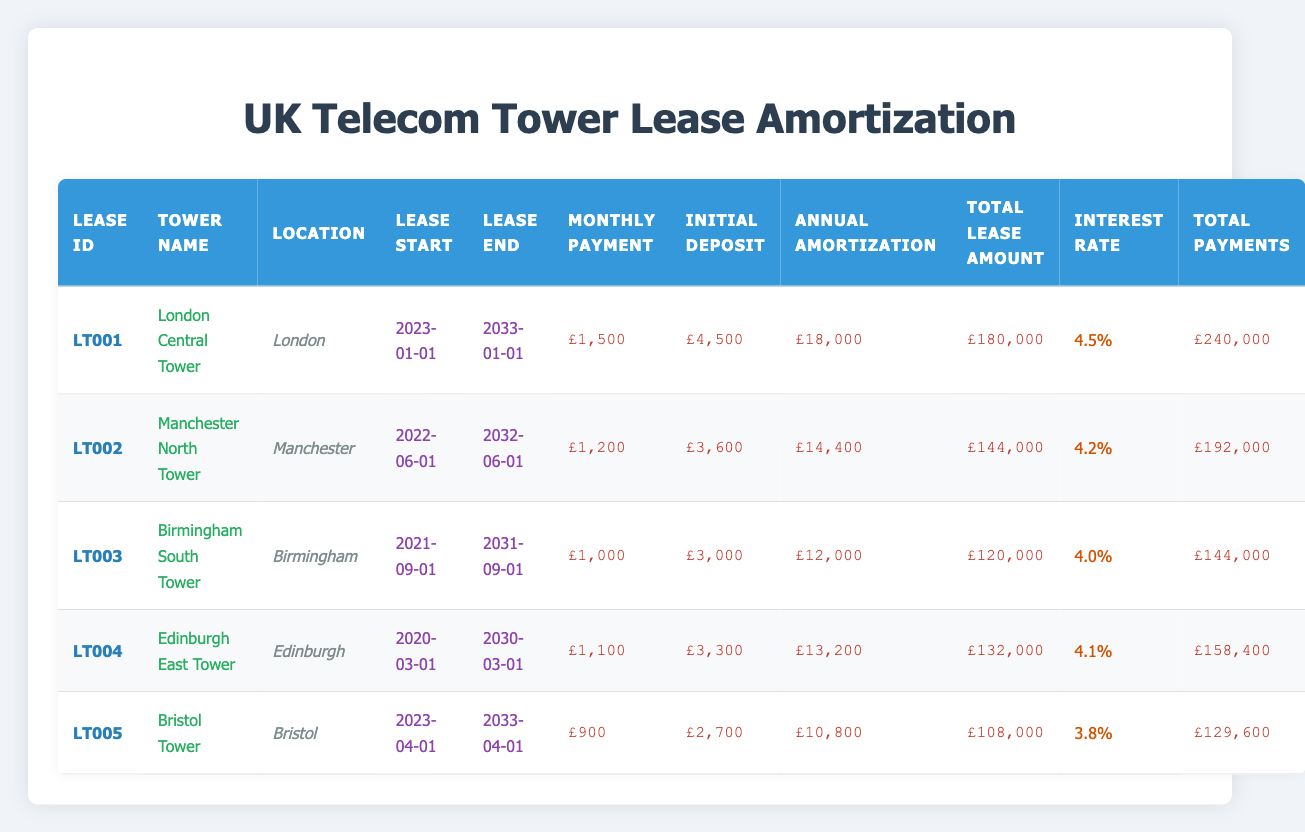What is the monthly lease payment for the "Bristol Tower"? By looking at the table, the entry for "Bristol Tower" indicates that the monthly lease payment is £900.
Answer: £900 Which tower has the highest total payments? Reviewing the "Total Payments" column, "London Central Tower" has the highest total payments of £240,000 compared to other towers.
Answer: £240,000 What is the average annual amortization amount across all telecom tower leases? The annual amortization amounts are £18,000, £14,400, £12,000, £13,200, and £10,800. Adding these together (18,000 + 14,400 + 12,000 + 13,200 + 10,800 = 68,400) and dividing by the number of leases (5) gives an average of £13,680.
Answer: £13,680 Is the lease for "Edinburgh East Tower" longer than 10 years? The lease starts on 2020-03-01 and ends on 2030-03-01, which is exactly 10 years, so it is not longer than 10 years.
Answer: No What is the difference between the total lease amounts of the "London Central Tower" and "Bristol Tower"? The total lease amounts are £180,000 for "London Central Tower" and £108,000 for "Bristol Tower". The difference is £180,000 - £108,000 = £72,000.
Answer: £72,000 Which tower has a lower interest rate: "Bristol Tower" or "Manchester North Tower"? "Bristol Tower" has an interest rate of 3.8%, while "Manchester North Tower" has an interest rate of 4.2%. Therefore, "Bristol Tower" has the lower interest rate.
Answer: Bristol Tower What is the total initial deposit for all telecom tower leases combined? The initial deposits listed are £4,500, £3,600, £3,000, £3,300, and £2,700. Adding these amounts together (4,500 + 3,600 + 3,000 + 3,300 + 2,700 = 17,100) gives a total initial deposit of £17,100.
Answer: £17,100 Is the "Birmingham South Tower" lease payment greater than £1,000? The lease payment for "Birmingham South Tower" is £1,000, which is not greater than £1,000.
Answer: No Which tower's lease has the latest start date? The "Bristol Tower" lease starts on 2023-04-01, which is the latest start date compared to the other towers.
Answer: Bristol Tower 